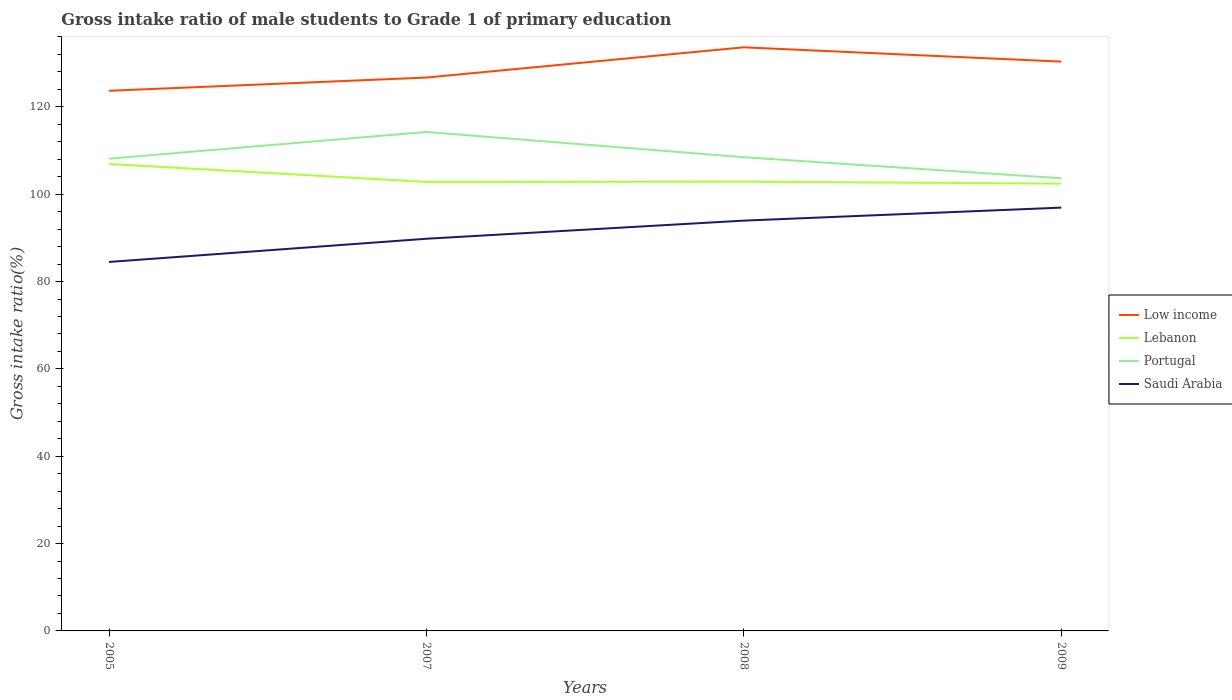Is the number of lines equal to the number of legend labels?
Give a very brief answer. Yes. Across all years, what is the maximum gross intake ratio in Saudi Arabia?
Your answer should be very brief. 84.49. In which year was the gross intake ratio in Lebanon maximum?
Offer a terse response. 2009. What is the total gross intake ratio in Lebanon in the graph?
Ensure brevity in your answer.  4.11. What is the difference between the highest and the second highest gross intake ratio in Lebanon?
Ensure brevity in your answer.  4.5. How many lines are there?
Keep it short and to the point. 4. How are the legend labels stacked?
Offer a very short reply. Vertical. What is the title of the graph?
Keep it short and to the point. Gross intake ratio of male students to Grade 1 of primary education. What is the label or title of the X-axis?
Your answer should be compact. Years. What is the label or title of the Y-axis?
Your response must be concise. Gross intake ratio(%). What is the Gross intake ratio(%) in Low income in 2005?
Keep it short and to the point. 123.68. What is the Gross intake ratio(%) of Lebanon in 2005?
Ensure brevity in your answer.  106.92. What is the Gross intake ratio(%) in Portugal in 2005?
Offer a very short reply. 108.13. What is the Gross intake ratio(%) in Saudi Arabia in 2005?
Your answer should be very brief. 84.49. What is the Gross intake ratio(%) in Low income in 2007?
Provide a short and direct response. 126.71. What is the Gross intake ratio(%) of Lebanon in 2007?
Offer a terse response. 102.81. What is the Gross intake ratio(%) in Portugal in 2007?
Give a very brief answer. 114.25. What is the Gross intake ratio(%) in Saudi Arabia in 2007?
Your answer should be very brief. 89.8. What is the Gross intake ratio(%) in Low income in 2008?
Keep it short and to the point. 133.63. What is the Gross intake ratio(%) in Lebanon in 2008?
Offer a terse response. 102.87. What is the Gross intake ratio(%) of Portugal in 2008?
Give a very brief answer. 108.47. What is the Gross intake ratio(%) in Saudi Arabia in 2008?
Give a very brief answer. 93.95. What is the Gross intake ratio(%) of Low income in 2009?
Your answer should be very brief. 130.35. What is the Gross intake ratio(%) in Lebanon in 2009?
Your response must be concise. 102.42. What is the Gross intake ratio(%) of Portugal in 2009?
Ensure brevity in your answer.  103.64. What is the Gross intake ratio(%) in Saudi Arabia in 2009?
Make the answer very short. 96.93. Across all years, what is the maximum Gross intake ratio(%) of Low income?
Make the answer very short. 133.63. Across all years, what is the maximum Gross intake ratio(%) of Lebanon?
Keep it short and to the point. 106.92. Across all years, what is the maximum Gross intake ratio(%) of Portugal?
Keep it short and to the point. 114.25. Across all years, what is the maximum Gross intake ratio(%) in Saudi Arabia?
Your response must be concise. 96.93. Across all years, what is the minimum Gross intake ratio(%) of Low income?
Keep it short and to the point. 123.68. Across all years, what is the minimum Gross intake ratio(%) of Lebanon?
Provide a succinct answer. 102.42. Across all years, what is the minimum Gross intake ratio(%) of Portugal?
Ensure brevity in your answer.  103.64. Across all years, what is the minimum Gross intake ratio(%) of Saudi Arabia?
Ensure brevity in your answer.  84.49. What is the total Gross intake ratio(%) in Low income in the graph?
Your answer should be compact. 514.37. What is the total Gross intake ratio(%) of Lebanon in the graph?
Provide a succinct answer. 415.01. What is the total Gross intake ratio(%) of Portugal in the graph?
Your response must be concise. 434.49. What is the total Gross intake ratio(%) in Saudi Arabia in the graph?
Make the answer very short. 365.16. What is the difference between the Gross intake ratio(%) in Low income in 2005 and that in 2007?
Offer a very short reply. -3.03. What is the difference between the Gross intake ratio(%) of Lebanon in 2005 and that in 2007?
Make the answer very short. 4.11. What is the difference between the Gross intake ratio(%) in Portugal in 2005 and that in 2007?
Provide a succinct answer. -6.12. What is the difference between the Gross intake ratio(%) in Saudi Arabia in 2005 and that in 2007?
Keep it short and to the point. -5.31. What is the difference between the Gross intake ratio(%) in Low income in 2005 and that in 2008?
Offer a very short reply. -9.95. What is the difference between the Gross intake ratio(%) of Lebanon in 2005 and that in 2008?
Provide a succinct answer. 4.05. What is the difference between the Gross intake ratio(%) of Portugal in 2005 and that in 2008?
Your response must be concise. -0.33. What is the difference between the Gross intake ratio(%) in Saudi Arabia in 2005 and that in 2008?
Your answer should be compact. -9.46. What is the difference between the Gross intake ratio(%) in Low income in 2005 and that in 2009?
Make the answer very short. -6.67. What is the difference between the Gross intake ratio(%) in Lebanon in 2005 and that in 2009?
Offer a terse response. 4.5. What is the difference between the Gross intake ratio(%) of Portugal in 2005 and that in 2009?
Offer a terse response. 4.49. What is the difference between the Gross intake ratio(%) of Saudi Arabia in 2005 and that in 2009?
Your answer should be very brief. -12.44. What is the difference between the Gross intake ratio(%) of Low income in 2007 and that in 2008?
Provide a short and direct response. -6.93. What is the difference between the Gross intake ratio(%) of Lebanon in 2007 and that in 2008?
Provide a succinct answer. -0.06. What is the difference between the Gross intake ratio(%) of Portugal in 2007 and that in 2008?
Your answer should be compact. 5.78. What is the difference between the Gross intake ratio(%) in Saudi Arabia in 2007 and that in 2008?
Your answer should be compact. -4.15. What is the difference between the Gross intake ratio(%) in Low income in 2007 and that in 2009?
Provide a short and direct response. -3.65. What is the difference between the Gross intake ratio(%) of Lebanon in 2007 and that in 2009?
Provide a succinct answer. 0.4. What is the difference between the Gross intake ratio(%) of Portugal in 2007 and that in 2009?
Make the answer very short. 10.61. What is the difference between the Gross intake ratio(%) of Saudi Arabia in 2007 and that in 2009?
Give a very brief answer. -7.13. What is the difference between the Gross intake ratio(%) of Low income in 2008 and that in 2009?
Your answer should be compact. 3.28. What is the difference between the Gross intake ratio(%) of Lebanon in 2008 and that in 2009?
Offer a terse response. 0.45. What is the difference between the Gross intake ratio(%) in Portugal in 2008 and that in 2009?
Your answer should be very brief. 4.82. What is the difference between the Gross intake ratio(%) of Saudi Arabia in 2008 and that in 2009?
Offer a terse response. -2.98. What is the difference between the Gross intake ratio(%) of Low income in 2005 and the Gross intake ratio(%) of Lebanon in 2007?
Provide a succinct answer. 20.87. What is the difference between the Gross intake ratio(%) of Low income in 2005 and the Gross intake ratio(%) of Portugal in 2007?
Your answer should be very brief. 9.43. What is the difference between the Gross intake ratio(%) of Low income in 2005 and the Gross intake ratio(%) of Saudi Arabia in 2007?
Your answer should be compact. 33.88. What is the difference between the Gross intake ratio(%) in Lebanon in 2005 and the Gross intake ratio(%) in Portugal in 2007?
Your answer should be very brief. -7.33. What is the difference between the Gross intake ratio(%) in Lebanon in 2005 and the Gross intake ratio(%) in Saudi Arabia in 2007?
Offer a terse response. 17.12. What is the difference between the Gross intake ratio(%) of Portugal in 2005 and the Gross intake ratio(%) of Saudi Arabia in 2007?
Give a very brief answer. 18.33. What is the difference between the Gross intake ratio(%) in Low income in 2005 and the Gross intake ratio(%) in Lebanon in 2008?
Give a very brief answer. 20.81. What is the difference between the Gross intake ratio(%) of Low income in 2005 and the Gross intake ratio(%) of Portugal in 2008?
Provide a short and direct response. 15.21. What is the difference between the Gross intake ratio(%) in Low income in 2005 and the Gross intake ratio(%) in Saudi Arabia in 2008?
Offer a terse response. 29.73. What is the difference between the Gross intake ratio(%) in Lebanon in 2005 and the Gross intake ratio(%) in Portugal in 2008?
Ensure brevity in your answer.  -1.55. What is the difference between the Gross intake ratio(%) in Lebanon in 2005 and the Gross intake ratio(%) in Saudi Arabia in 2008?
Provide a short and direct response. 12.97. What is the difference between the Gross intake ratio(%) in Portugal in 2005 and the Gross intake ratio(%) in Saudi Arabia in 2008?
Your answer should be very brief. 14.18. What is the difference between the Gross intake ratio(%) of Low income in 2005 and the Gross intake ratio(%) of Lebanon in 2009?
Ensure brevity in your answer.  21.26. What is the difference between the Gross intake ratio(%) in Low income in 2005 and the Gross intake ratio(%) in Portugal in 2009?
Ensure brevity in your answer.  20.04. What is the difference between the Gross intake ratio(%) in Low income in 2005 and the Gross intake ratio(%) in Saudi Arabia in 2009?
Give a very brief answer. 26.75. What is the difference between the Gross intake ratio(%) of Lebanon in 2005 and the Gross intake ratio(%) of Portugal in 2009?
Make the answer very short. 3.28. What is the difference between the Gross intake ratio(%) of Lebanon in 2005 and the Gross intake ratio(%) of Saudi Arabia in 2009?
Offer a very short reply. 9.99. What is the difference between the Gross intake ratio(%) of Portugal in 2005 and the Gross intake ratio(%) of Saudi Arabia in 2009?
Keep it short and to the point. 11.2. What is the difference between the Gross intake ratio(%) of Low income in 2007 and the Gross intake ratio(%) of Lebanon in 2008?
Make the answer very short. 23.84. What is the difference between the Gross intake ratio(%) in Low income in 2007 and the Gross intake ratio(%) in Portugal in 2008?
Your answer should be compact. 18.24. What is the difference between the Gross intake ratio(%) in Low income in 2007 and the Gross intake ratio(%) in Saudi Arabia in 2008?
Your answer should be very brief. 32.76. What is the difference between the Gross intake ratio(%) in Lebanon in 2007 and the Gross intake ratio(%) in Portugal in 2008?
Keep it short and to the point. -5.65. What is the difference between the Gross intake ratio(%) of Lebanon in 2007 and the Gross intake ratio(%) of Saudi Arabia in 2008?
Offer a terse response. 8.86. What is the difference between the Gross intake ratio(%) in Portugal in 2007 and the Gross intake ratio(%) in Saudi Arabia in 2008?
Your response must be concise. 20.3. What is the difference between the Gross intake ratio(%) of Low income in 2007 and the Gross intake ratio(%) of Lebanon in 2009?
Keep it short and to the point. 24.29. What is the difference between the Gross intake ratio(%) in Low income in 2007 and the Gross intake ratio(%) in Portugal in 2009?
Offer a very short reply. 23.06. What is the difference between the Gross intake ratio(%) in Low income in 2007 and the Gross intake ratio(%) in Saudi Arabia in 2009?
Your answer should be compact. 29.78. What is the difference between the Gross intake ratio(%) of Lebanon in 2007 and the Gross intake ratio(%) of Portugal in 2009?
Ensure brevity in your answer.  -0.83. What is the difference between the Gross intake ratio(%) of Lebanon in 2007 and the Gross intake ratio(%) of Saudi Arabia in 2009?
Your response must be concise. 5.88. What is the difference between the Gross intake ratio(%) of Portugal in 2007 and the Gross intake ratio(%) of Saudi Arabia in 2009?
Make the answer very short. 17.32. What is the difference between the Gross intake ratio(%) in Low income in 2008 and the Gross intake ratio(%) in Lebanon in 2009?
Your answer should be compact. 31.22. What is the difference between the Gross intake ratio(%) of Low income in 2008 and the Gross intake ratio(%) of Portugal in 2009?
Give a very brief answer. 29.99. What is the difference between the Gross intake ratio(%) of Low income in 2008 and the Gross intake ratio(%) of Saudi Arabia in 2009?
Give a very brief answer. 36.71. What is the difference between the Gross intake ratio(%) in Lebanon in 2008 and the Gross intake ratio(%) in Portugal in 2009?
Offer a terse response. -0.77. What is the difference between the Gross intake ratio(%) of Lebanon in 2008 and the Gross intake ratio(%) of Saudi Arabia in 2009?
Give a very brief answer. 5.94. What is the difference between the Gross intake ratio(%) of Portugal in 2008 and the Gross intake ratio(%) of Saudi Arabia in 2009?
Offer a very short reply. 11.54. What is the average Gross intake ratio(%) in Low income per year?
Offer a terse response. 128.59. What is the average Gross intake ratio(%) of Lebanon per year?
Your answer should be very brief. 103.75. What is the average Gross intake ratio(%) in Portugal per year?
Make the answer very short. 108.62. What is the average Gross intake ratio(%) of Saudi Arabia per year?
Your answer should be very brief. 91.29. In the year 2005, what is the difference between the Gross intake ratio(%) in Low income and Gross intake ratio(%) in Lebanon?
Your answer should be very brief. 16.76. In the year 2005, what is the difference between the Gross intake ratio(%) in Low income and Gross intake ratio(%) in Portugal?
Offer a terse response. 15.55. In the year 2005, what is the difference between the Gross intake ratio(%) of Low income and Gross intake ratio(%) of Saudi Arabia?
Give a very brief answer. 39.19. In the year 2005, what is the difference between the Gross intake ratio(%) in Lebanon and Gross intake ratio(%) in Portugal?
Offer a terse response. -1.21. In the year 2005, what is the difference between the Gross intake ratio(%) of Lebanon and Gross intake ratio(%) of Saudi Arabia?
Make the answer very short. 22.43. In the year 2005, what is the difference between the Gross intake ratio(%) of Portugal and Gross intake ratio(%) of Saudi Arabia?
Your response must be concise. 23.65. In the year 2007, what is the difference between the Gross intake ratio(%) of Low income and Gross intake ratio(%) of Lebanon?
Provide a short and direct response. 23.89. In the year 2007, what is the difference between the Gross intake ratio(%) in Low income and Gross intake ratio(%) in Portugal?
Keep it short and to the point. 12.46. In the year 2007, what is the difference between the Gross intake ratio(%) of Low income and Gross intake ratio(%) of Saudi Arabia?
Give a very brief answer. 36.91. In the year 2007, what is the difference between the Gross intake ratio(%) of Lebanon and Gross intake ratio(%) of Portugal?
Your answer should be very brief. -11.44. In the year 2007, what is the difference between the Gross intake ratio(%) in Lebanon and Gross intake ratio(%) in Saudi Arabia?
Give a very brief answer. 13.01. In the year 2007, what is the difference between the Gross intake ratio(%) of Portugal and Gross intake ratio(%) of Saudi Arabia?
Your response must be concise. 24.45. In the year 2008, what is the difference between the Gross intake ratio(%) of Low income and Gross intake ratio(%) of Lebanon?
Provide a succinct answer. 30.77. In the year 2008, what is the difference between the Gross intake ratio(%) of Low income and Gross intake ratio(%) of Portugal?
Your response must be concise. 25.17. In the year 2008, what is the difference between the Gross intake ratio(%) of Low income and Gross intake ratio(%) of Saudi Arabia?
Keep it short and to the point. 39.68. In the year 2008, what is the difference between the Gross intake ratio(%) of Lebanon and Gross intake ratio(%) of Portugal?
Give a very brief answer. -5.6. In the year 2008, what is the difference between the Gross intake ratio(%) of Lebanon and Gross intake ratio(%) of Saudi Arabia?
Your response must be concise. 8.92. In the year 2008, what is the difference between the Gross intake ratio(%) in Portugal and Gross intake ratio(%) in Saudi Arabia?
Your answer should be very brief. 14.52. In the year 2009, what is the difference between the Gross intake ratio(%) in Low income and Gross intake ratio(%) in Lebanon?
Offer a very short reply. 27.94. In the year 2009, what is the difference between the Gross intake ratio(%) in Low income and Gross intake ratio(%) in Portugal?
Provide a short and direct response. 26.71. In the year 2009, what is the difference between the Gross intake ratio(%) in Low income and Gross intake ratio(%) in Saudi Arabia?
Provide a succinct answer. 33.43. In the year 2009, what is the difference between the Gross intake ratio(%) in Lebanon and Gross intake ratio(%) in Portugal?
Your response must be concise. -1.23. In the year 2009, what is the difference between the Gross intake ratio(%) of Lebanon and Gross intake ratio(%) of Saudi Arabia?
Offer a terse response. 5.49. In the year 2009, what is the difference between the Gross intake ratio(%) of Portugal and Gross intake ratio(%) of Saudi Arabia?
Ensure brevity in your answer.  6.71. What is the ratio of the Gross intake ratio(%) in Low income in 2005 to that in 2007?
Make the answer very short. 0.98. What is the ratio of the Gross intake ratio(%) in Lebanon in 2005 to that in 2007?
Keep it short and to the point. 1.04. What is the ratio of the Gross intake ratio(%) in Portugal in 2005 to that in 2007?
Offer a very short reply. 0.95. What is the ratio of the Gross intake ratio(%) of Saudi Arabia in 2005 to that in 2007?
Your answer should be compact. 0.94. What is the ratio of the Gross intake ratio(%) in Low income in 2005 to that in 2008?
Your answer should be compact. 0.93. What is the ratio of the Gross intake ratio(%) in Lebanon in 2005 to that in 2008?
Your answer should be compact. 1.04. What is the ratio of the Gross intake ratio(%) of Saudi Arabia in 2005 to that in 2008?
Your response must be concise. 0.9. What is the ratio of the Gross intake ratio(%) in Low income in 2005 to that in 2009?
Your response must be concise. 0.95. What is the ratio of the Gross intake ratio(%) in Lebanon in 2005 to that in 2009?
Your response must be concise. 1.04. What is the ratio of the Gross intake ratio(%) in Portugal in 2005 to that in 2009?
Provide a short and direct response. 1.04. What is the ratio of the Gross intake ratio(%) in Saudi Arabia in 2005 to that in 2009?
Provide a short and direct response. 0.87. What is the ratio of the Gross intake ratio(%) of Low income in 2007 to that in 2008?
Offer a terse response. 0.95. What is the ratio of the Gross intake ratio(%) in Portugal in 2007 to that in 2008?
Give a very brief answer. 1.05. What is the ratio of the Gross intake ratio(%) of Saudi Arabia in 2007 to that in 2008?
Your response must be concise. 0.96. What is the ratio of the Gross intake ratio(%) in Low income in 2007 to that in 2009?
Your answer should be compact. 0.97. What is the ratio of the Gross intake ratio(%) in Portugal in 2007 to that in 2009?
Your answer should be compact. 1.1. What is the ratio of the Gross intake ratio(%) of Saudi Arabia in 2007 to that in 2009?
Give a very brief answer. 0.93. What is the ratio of the Gross intake ratio(%) of Low income in 2008 to that in 2009?
Your response must be concise. 1.03. What is the ratio of the Gross intake ratio(%) in Lebanon in 2008 to that in 2009?
Offer a very short reply. 1. What is the ratio of the Gross intake ratio(%) in Portugal in 2008 to that in 2009?
Give a very brief answer. 1.05. What is the ratio of the Gross intake ratio(%) in Saudi Arabia in 2008 to that in 2009?
Give a very brief answer. 0.97. What is the difference between the highest and the second highest Gross intake ratio(%) in Low income?
Offer a terse response. 3.28. What is the difference between the highest and the second highest Gross intake ratio(%) in Lebanon?
Keep it short and to the point. 4.05. What is the difference between the highest and the second highest Gross intake ratio(%) in Portugal?
Your response must be concise. 5.78. What is the difference between the highest and the second highest Gross intake ratio(%) in Saudi Arabia?
Your answer should be compact. 2.98. What is the difference between the highest and the lowest Gross intake ratio(%) of Low income?
Make the answer very short. 9.95. What is the difference between the highest and the lowest Gross intake ratio(%) in Lebanon?
Provide a succinct answer. 4.5. What is the difference between the highest and the lowest Gross intake ratio(%) in Portugal?
Your answer should be compact. 10.61. What is the difference between the highest and the lowest Gross intake ratio(%) of Saudi Arabia?
Offer a terse response. 12.44. 